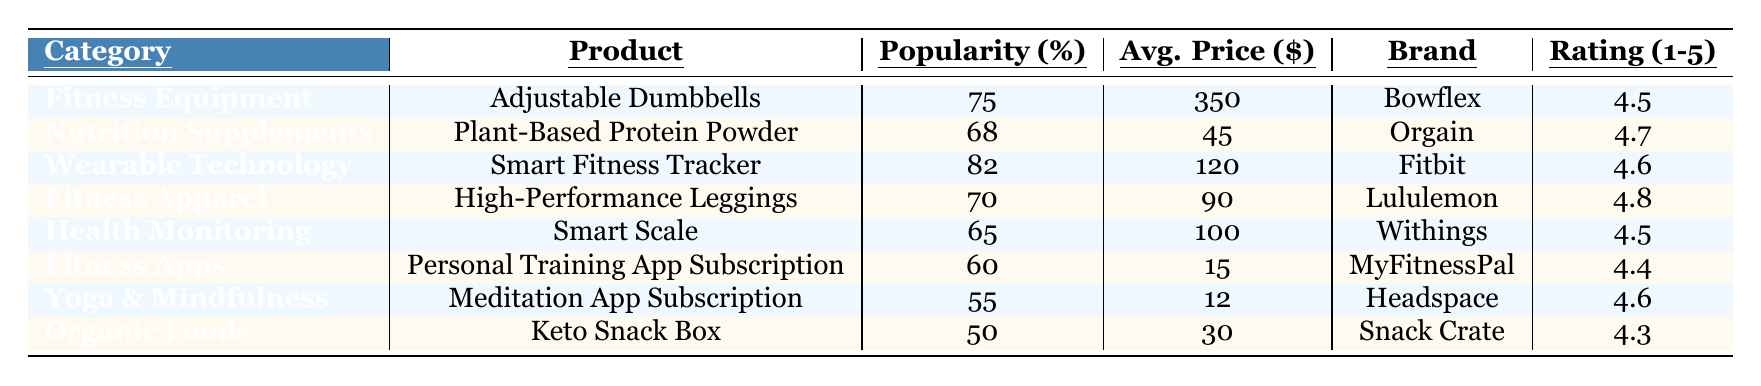What is the most popular product in the table? The table indicates that the "Smart Fitness Tracker" has the highest popularity percentage at 82%.
Answer: Smart Fitness Tracker Which product has the highest consumer rating? By reviewing the consumer ratings, "High-Performance Leggings" has the highest rating of 4.8 out of 5.
Answer: High-Performance Leggings What is the average price of the fitness equipment listed? The average price can be calculated by adding the price of "Adjustable Dumbbells" ($350). There is only one fitness product.
Answer: 350 What is the popularity difference between "Plant-Based Protein Powder" and "Keto Snack Box"? The popularity of "Plant-Based Protein Powder" is 68%, and "Keto Snack Box" is 50%. The difference is calculated as 68 - 50 = 18%.
Answer: 18% How many products have an average price above $100? The products that exceed $100 are "Adjustable Dumbbells" ($350), "Smart Fitness Tracker" ($120), and "Smart Scale" ($100). Thus, there are 3 products.
Answer: 3 Does "MyFitnessPal" have a higher average price than "Headspace"? "MyFitnessPal" has an average price of $15 while "Headspace" is $12, indicating that it is higher.
Answer: Yes What is the average consumer rating of the products listed in the table? The consumer ratings are 4.5, 4.7, 4.6, 4.8, 4.5, 4.4, 4.6, and 4.3. The total sum is 36.4, and there are 8 products. So, the average is 36.4/8 = 4.55.
Answer: 4.55 How does the popularity of fitness apps compare to wearable technology? "Personal Training App Subscription" has a popularity of 60%, while "Smart Fitness Tracker" has 82%. The comparison shows that wearable technology is more popular.
Answer: Wearable technology is more popular What is the total average price of all the products combined? The total price is $350 + $45 + $120 + $90 + $100 + $15 + $12 + $30 = $762. Since there are 8 products, the average price is $762/8 = $95.25.
Answer: 95.25 Is "Lululemon" a brand associated with fitness apparel? Yes, the table lists "Lululemon" as the brand for "High-Performance Leggings," which is categorized under fitness apparel.
Answer: Yes 